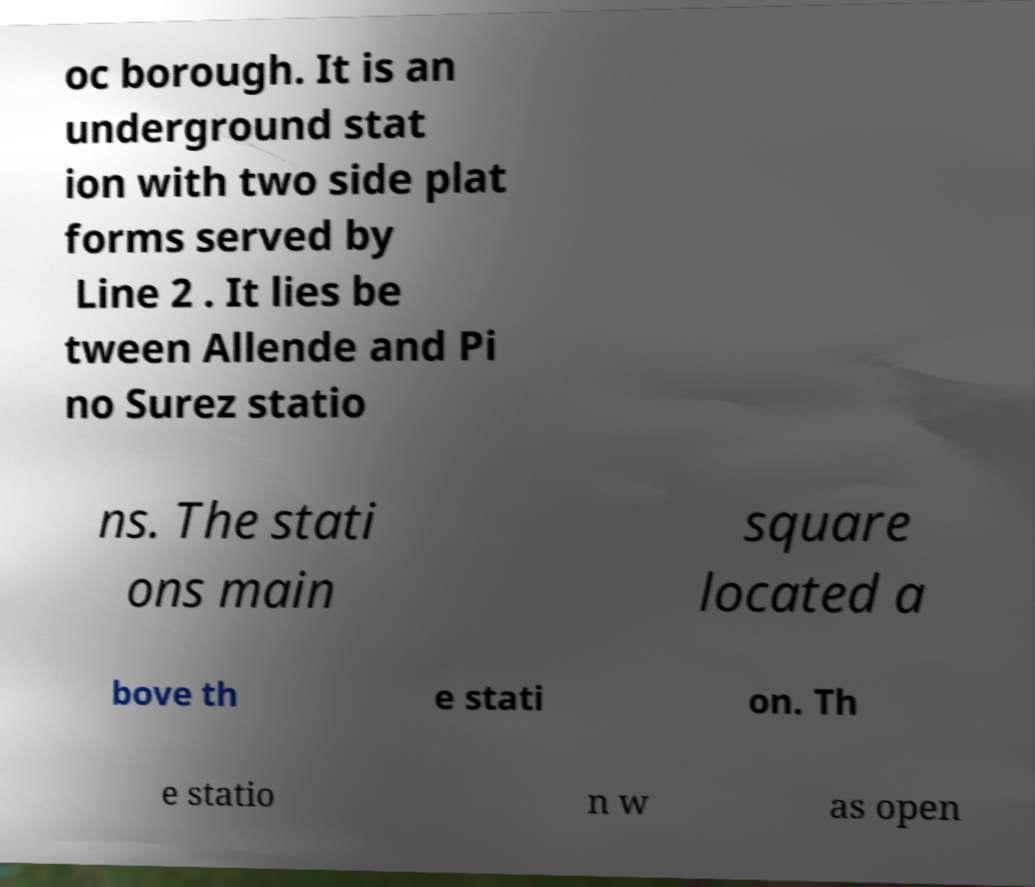Could you extract and type out the text from this image? oc borough. It is an underground stat ion with two side plat forms served by Line 2 . It lies be tween Allende and Pi no Surez statio ns. The stati ons main square located a bove th e stati on. Th e statio n w as open 